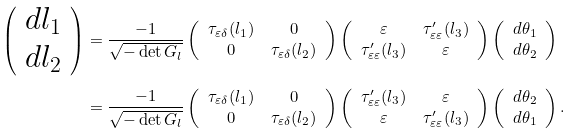<formula> <loc_0><loc_0><loc_500><loc_500>\left ( \begin{array} { c c c } d l _ { 1 } \\ d l _ { 2 } \end{array} \right ) & = \frac { - 1 } { \sqrt { - \det G _ { l } } } \left ( \begin{array} { c c c } \tau _ { \varepsilon \delta } ( l _ { 1 } ) & 0 \\ 0 & \tau _ { \varepsilon \delta } ( l _ { 2 } ) \end{array} \right ) \left ( \begin{array} { c c c } \varepsilon & \tau _ { \varepsilon \varepsilon } ^ { \prime } ( l _ { 3 } ) \\ \tau _ { \varepsilon \varepsilon } ^ { \prime } ( l _ { 3 } ) & \varepsilon \end{array} \right ) \left ( \begin{array} { c c c } d \theta _ { 1 } \\ d \theta _ { 2 } \end{array} \right ) \\ & = \frac { - 1 } { \sqrt { - \det G _ { l } } } \left ( \begin{array} { c c c } \tau _ { \varepsilon \delta } ( l _ { 1 } ) & 0 \\ 0 & \tau _ { \varepsilon \delta } ( l _ { 2 } ) \end{array} \right ) \left ( \begin{array} { c c c } \tau _ { \varepsilon \varepsilon } ^ { \prime } ( l _ { 3 } ) & \varepsilon \\ \varepsilon & \tau _ { \varepsilon \varepsilon } ^ { \prime } ( l _ { 3 } ) \end{array} \right ) \left ( \begin{array} { c c c } d \theta _ { 2 } \\ d \theta _ { 1 } \end{array} \right ) .</formula> 